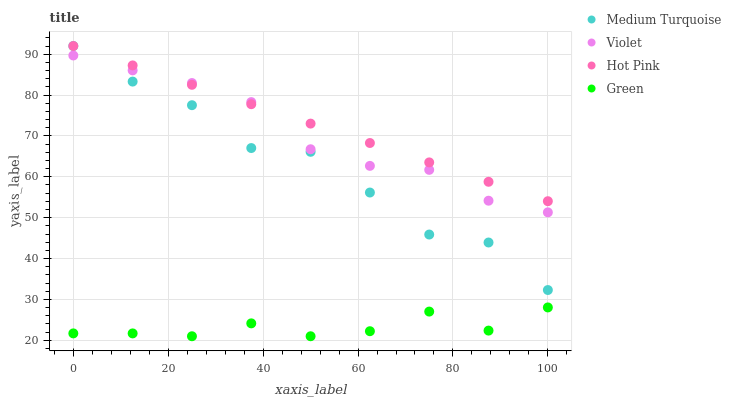Does Green have the minimum area under the curve?
Answer yes or no. Yes. Does Hot Pink have the maximum area under the curve?
Answer yes or no. Yes. Does Medium Turquoise have the minimum area under the curve?
Answer yes or no. No. Does Medium Turquoise have the maximum area under the curve?
Answer yes or no. No. Is Hot Pink the smoothest?
Answer yes or no. Yes. Is Medium Turquoise the roughest?
Answer yes or no. Yes. Is Green the smoothest?
Answer yes or no. No. Is Green the roughest?
Answer yes or no. No. Does Green have the lowest value?
Answer yes or no. Yes. Does Medium Turquoise have the lowest value?
Answer yes or no. No. Does Medium Turquoise have the highest value?
Answer yes or no. Yes. Does Green have the highest value?
Answer yes or no. No. Is Green less than Hot Pink?
Answer yes or no. Yes. Is Violet greater than Green?
Answer yes or no. Yes. Does Violet intersect Hot Pink?
Answer yes or no. Yes. Is Violet less than Hot Pink?
Answer yes or no. No. Is Violet greater than Hot Pink?
Answer yes or no. No. Does Green intersect Hot Pink?
Answer yes or no. No. 